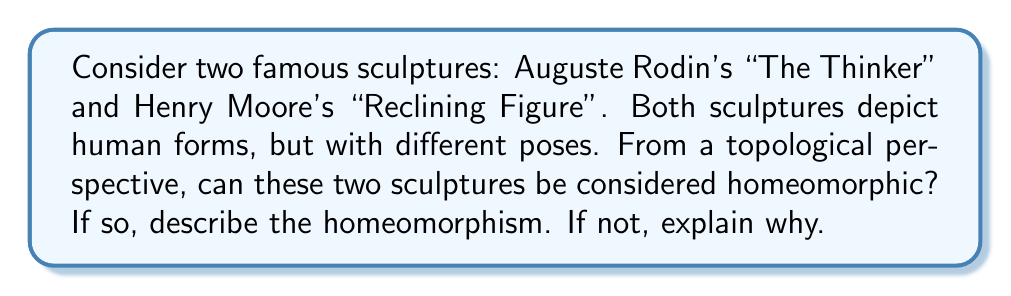Could you help me with this problem? To approach this problem, we need to consider the fundamental topological properties of the sculptures:

1. Genus: Both sculptures represent human figures, which topologically can be considered as solid objects with no holes passing completely through them. Therefore, both have a genus of 0.

2. Connectedness: Both sculptures are single, connected pieces.

3. Compactness: Both sculptures are bounded and closed subsets of $\mathbb{R}^3$, making them compact.

4. Orientability: Both sculptures have a well-defined "inside" and "outside", making them orientable.

5. Dimensionality: Both sculptures are three-dimensional objects.

Given these properties, we can conclude that the two sculptures are indeed homeomorphic. A homeomorphism between them can be described as a continuous deformation that doesn't involve cutting, tearing, or gluing.

To visualize this homeomorphism:

1. Start with "The Thinker" in its seated position.
2. Gradually straighten the legs and torso.
3. Rotate the figure to a reclining position.
4. Adjust the arms and head to match the "Reclining Figure" pose.

This process can be described mathematically as a continuous function $f: X \to Y$, where $X$ represents "The Thinker" and $Y$ represents "Reclining Figure". The function $f$ is bijective, continuous, and has a continuous inverse $f^{-1}: Y \to X$.

It's important to note that while the artistic details and exact shapes differ between the sculptures, from a topological perspective, these differences are irrelevant. Topology is concerned with properties that remain unchanged under continuous deformations, and both sculptures can be continuously deformed into each other without changing their fundamental topological structure.
Answer: Yes, Auguste Rodin's "The Thinker" and Henry Moore's "Reclining Figure" are topologically homeomorphic. A homeomorphism between them can be described as a continuous deformation that transforms one sculpture into the other without cutting, tearing, or gluing, preserving their topological properties such as genus (0), connectedness, compactness, orientability, and dimensionality. 